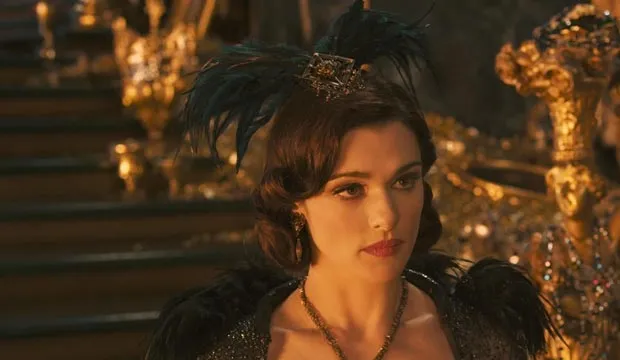Can you provide some background information about the character Evanora? Evanora is a central character in 'Oz the Great and Powerful.' She is one of the witches vying for control of the Land of Oz. Evanora is known for her cunning and manipulative nature, often using her charm and intelligence to achieve her goals. Her character is shrouded in mystery and intrigue, adding depth to the storyline. 